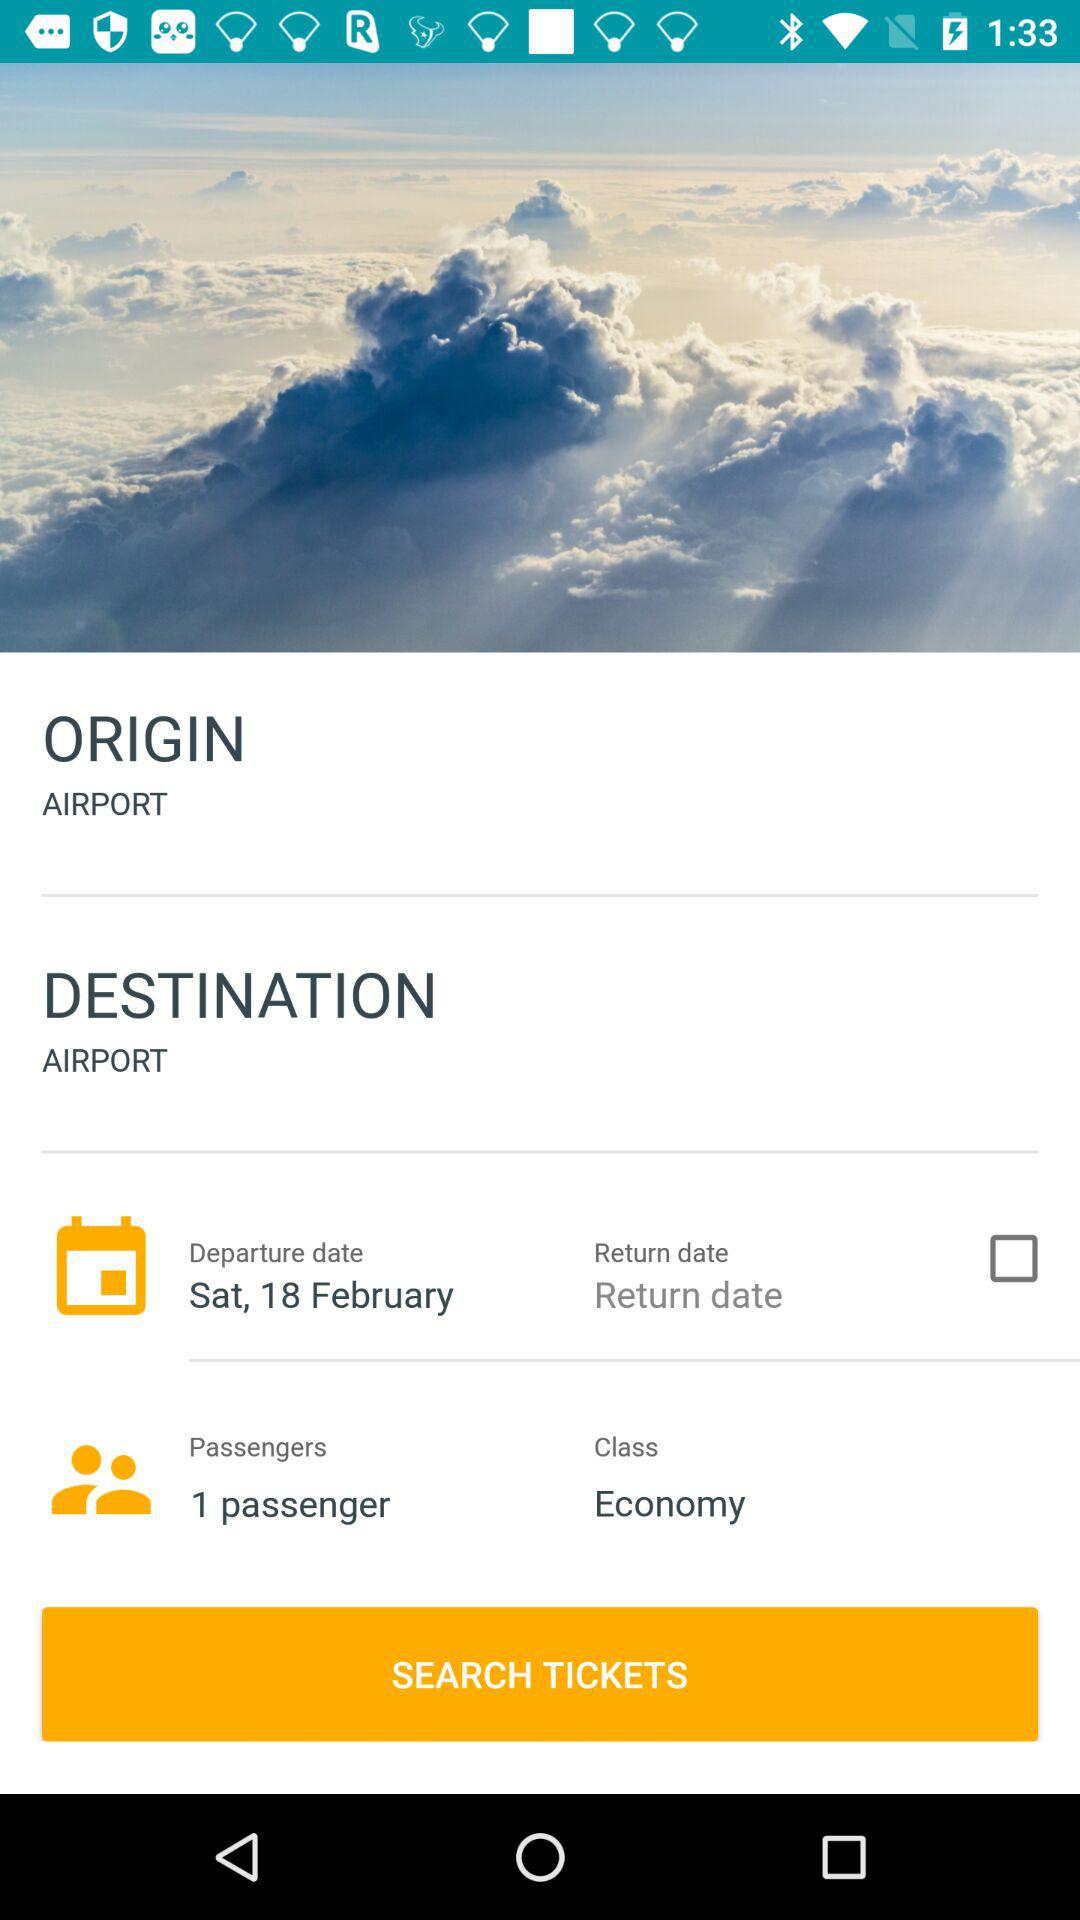How many passengers are there? There is 1 passenger. 